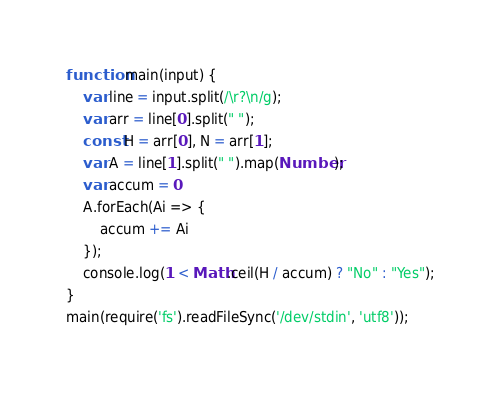<code> <loc_0><loc_0><loc_500><loc_500><_JavaScript_>function main(input) {
    var line = input.split(/\r?\n/g);
    var arr = line[0].split(" ");
    const H = arr[0], N = arr[1];
    var A = line[1].split(" ").map(Number);
    var accum = 0
    A.forEach(Ai => {
        accum += Ai
    });
    console.log(1 < Math.ceil(H / accum) ? "No" : "Yes");
}
main(require('fs').readFileSync('/dev/stdin', 'utf8'));</code> 